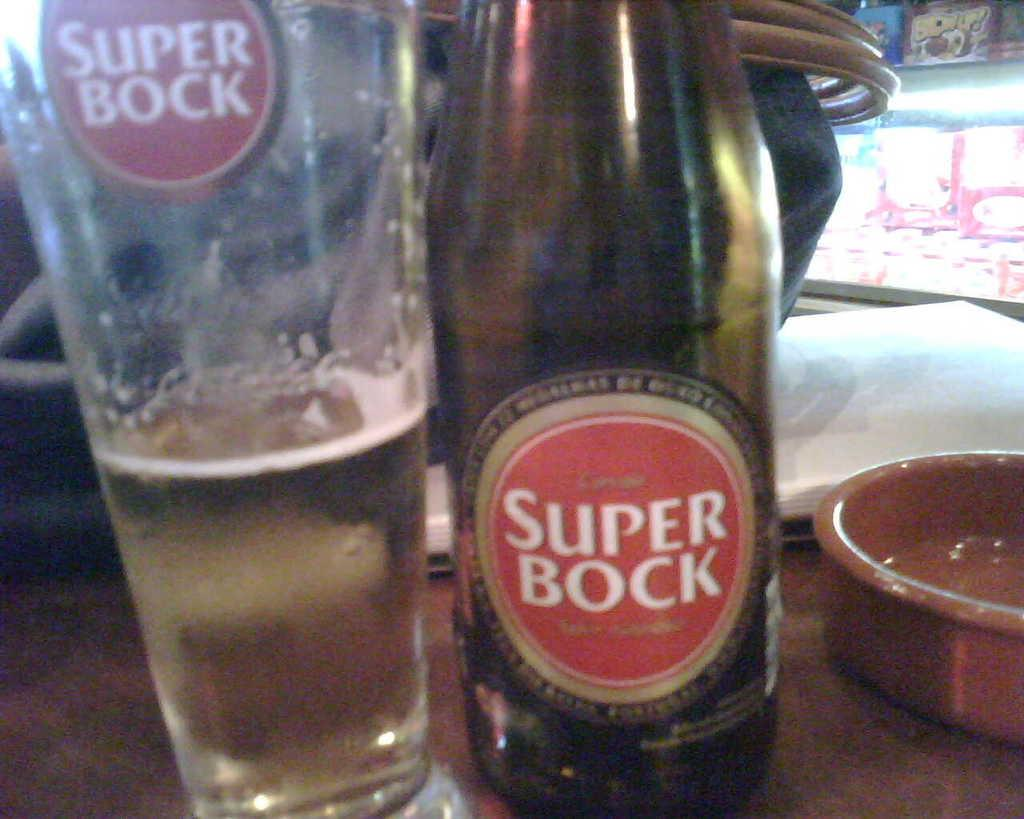<image>
Describe the image concisely. A glass of beer is poured into a glass from a Super Bock bottle 